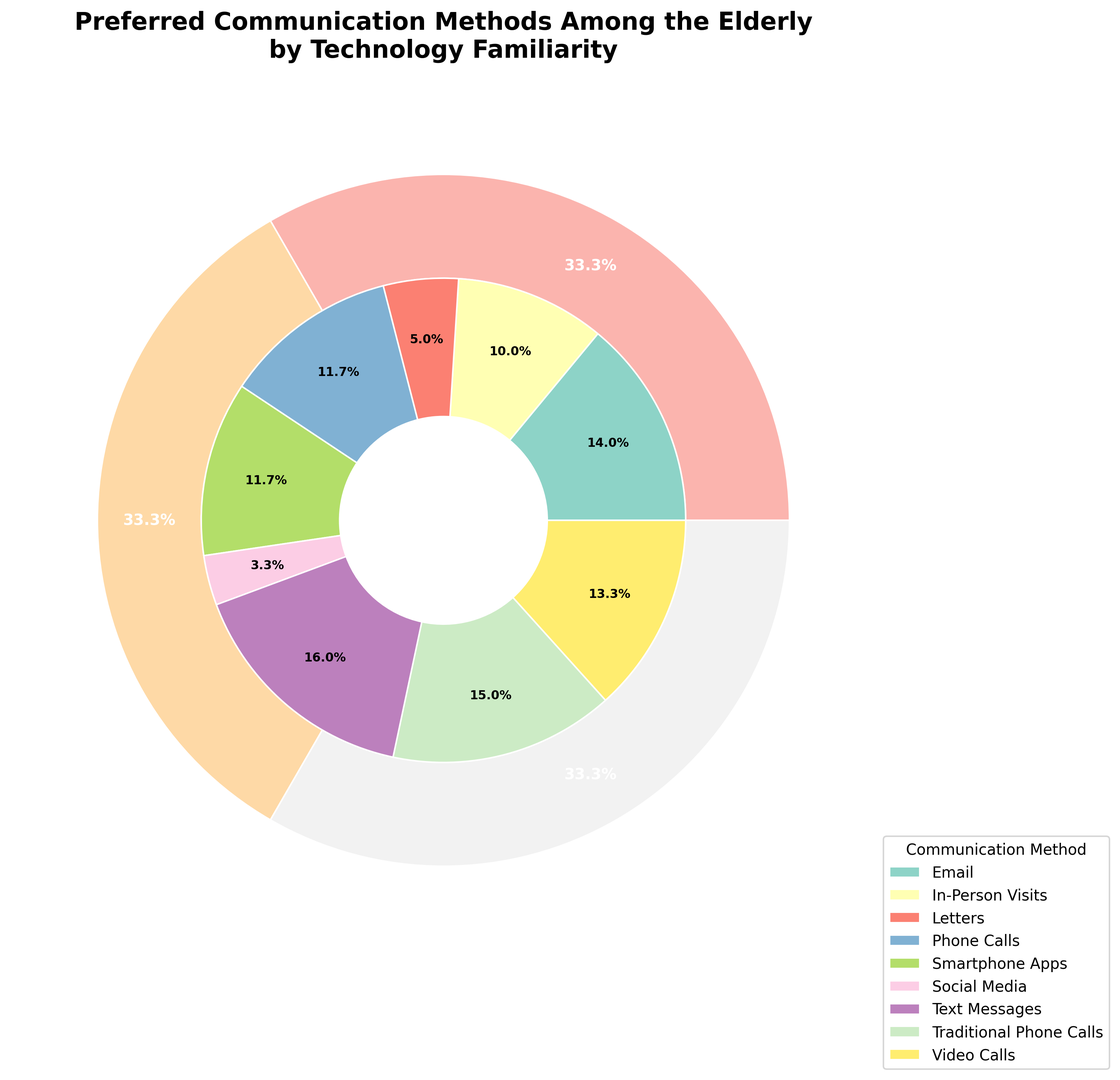What percentage of elderly people with high technology familiarity prefers text messages? Reference the inner circle to find the segment labeled "Text Messages" and check the corresponding percentage label.
Answer: 20% Which communication method has the highest percentage overall? Compare the segments in the inner pie chart for the communication methods and look for the highest percentage label.
Answer: Traditional Phone Calls How does the preference for email change with technology familiarity? Look at the segments labeled "Email" in each outer tech-level segment and compare the percentage values: 15% for High, 20% for Medium, and 7% for Low.
Answer: Decreases Is the preference for smartphone apps higher in the high or medium technology familiarity group? Compare the outer segments for smartphone apps in the high (30%) and medium (5%) technology familiarity groups.
Answer: High What is the total percentage for visual communication methods among the elderly with high technology familiarity (Video Calls and Social Media)? Sum the percentages for Video Calls (25%) and Social Media (10%) under the high technology familiarity category.
Answer: 35% Which communication method is least preferred by the elderly with low technology familiarity? Reference the segments for each method in the low technology familiarity section and identify the lowest percentage, which is "Text Messages" at 3%.
Answer: Text Messages Compare the preference for traditional phone calls among elderly with medium and low technology familiarity. Check the segments for traditional phone calls and compare them: it's 35% for Medium and 45% for Low technology familiarity.
Answer: Lower in Medium What is the combined percentage of elderly with medium and low technology familiarity who prefer text messages? Add the percentages for text messages from the medium (25%) and low (3%) technology familiarity groups.
Answer: 28% 